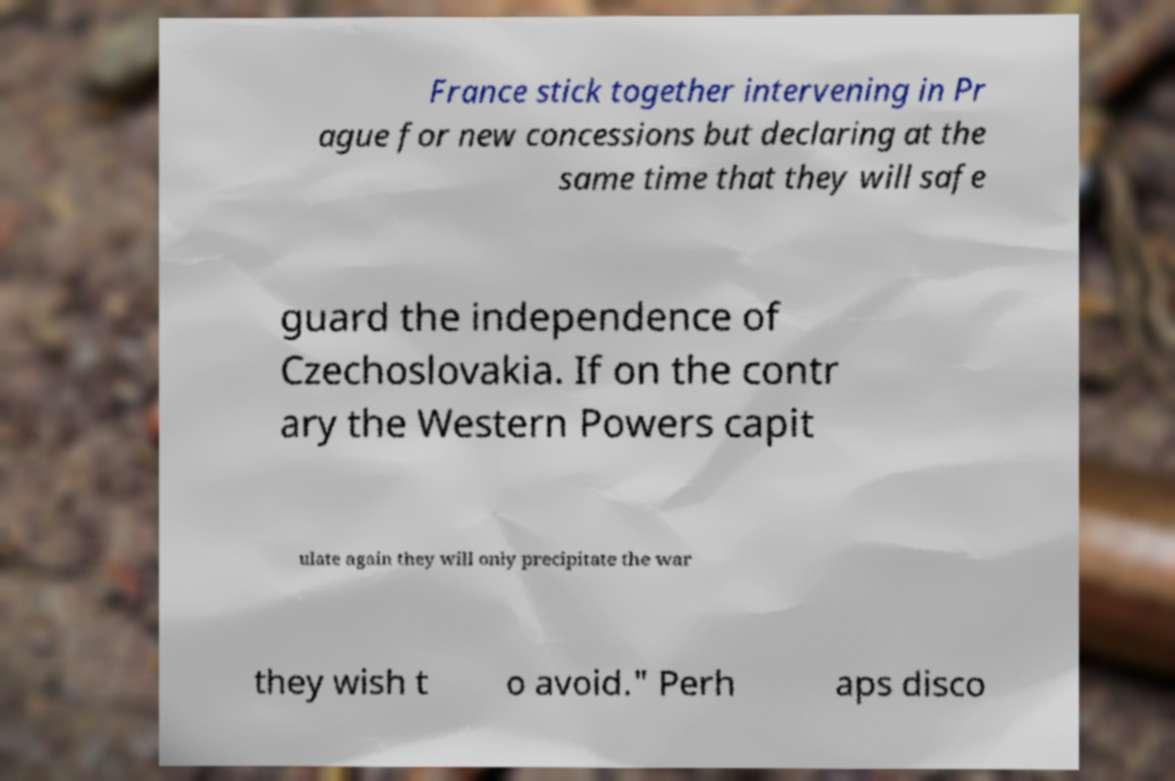I need the written content from this picture converted into text. Can you do that? France stick together intervening in Pr ague for new concessions but declaring at the same time that they will safe guard the independence of Czechoslovakia. If on the contr ary the Western Powers capit ulate again they will only precipitate the war they wish t o avoid." Perh aps disco 